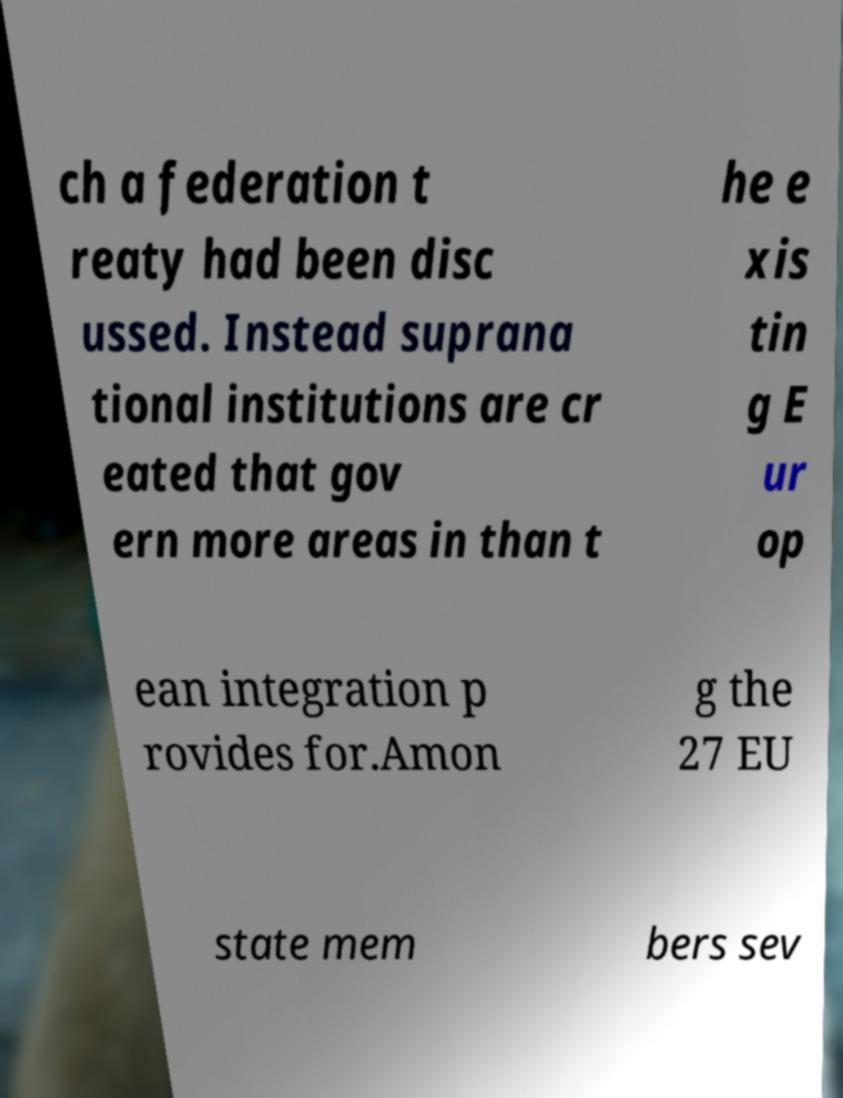I need the written content from this picture converted into text. Can you do that? ch a federation t reaty had been disc ussed. Instead suprana tional institutions are cr eated that gov ern more areas in than t he e xis tin g E ur op ean integration p rovides for.Amon g the 27 EU state mem bers sev 